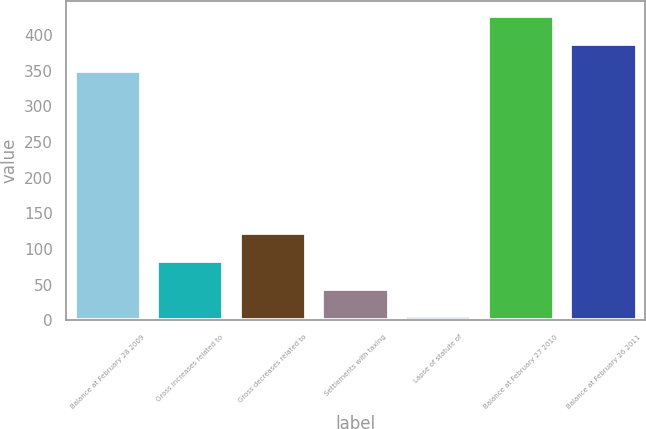Convert chart to OTSL. <chart><loc_0><loc_0><loc_500><loc_500><bar_chart><fcel>Balance at February 28 2009<fcel>Gross increases related to<fcel>Gross decreases related to<fcel>Settlements with taxing<fcel>Lapse of statute of<fcel>Balance at February 27 2010<fcel>Balance at February 26 2011<nl><fcel>349<fcel>83.4<fcel>122.1<fcel>44.7<fcel>6<fcel>426.4<fcel>387.7<nl></chart> 